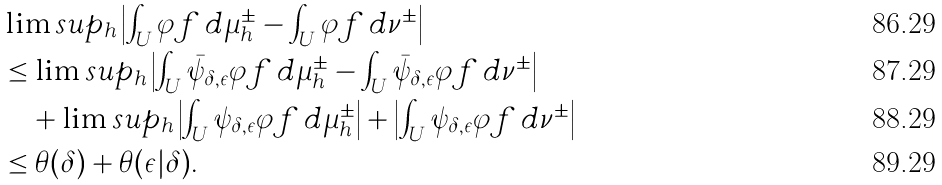<formula> <loc_0><loc_0><loc_500><loc_500>& \lim s u p _ { h } \left | \int _ { U } \varphi f \, d \mu _ { h } ^ { \pm } - \int _ { U } \varphi f \, d \nu ^ { \pm } \right | \\ & \leq \lim s u p _ { h } \left | \int _ { U } \bar { \psi } _ { \delta , \epsilon } \varphi f \, d \mu _ { h } ^ { \pm } - \int _ { U } \bar { \psi } _ { \delta , \epsilon } \varphi f \, d \nu ^ { \pm } \right | \\ & \quad + \lim s u p _ { h } \left | \int _ { U } \psi _ { \delta , \epsilon } \varphi f \, d \mu _ { h } ^ { \pm } \right | + \left | \int _ { U } \psi _ { \delta , \epsilon } \varphi f \, d \nu ^ { \pm } \right | \\ & \leq \theta ( \delta ) + \theta ( \epsilon | \delta ) .</formula> 